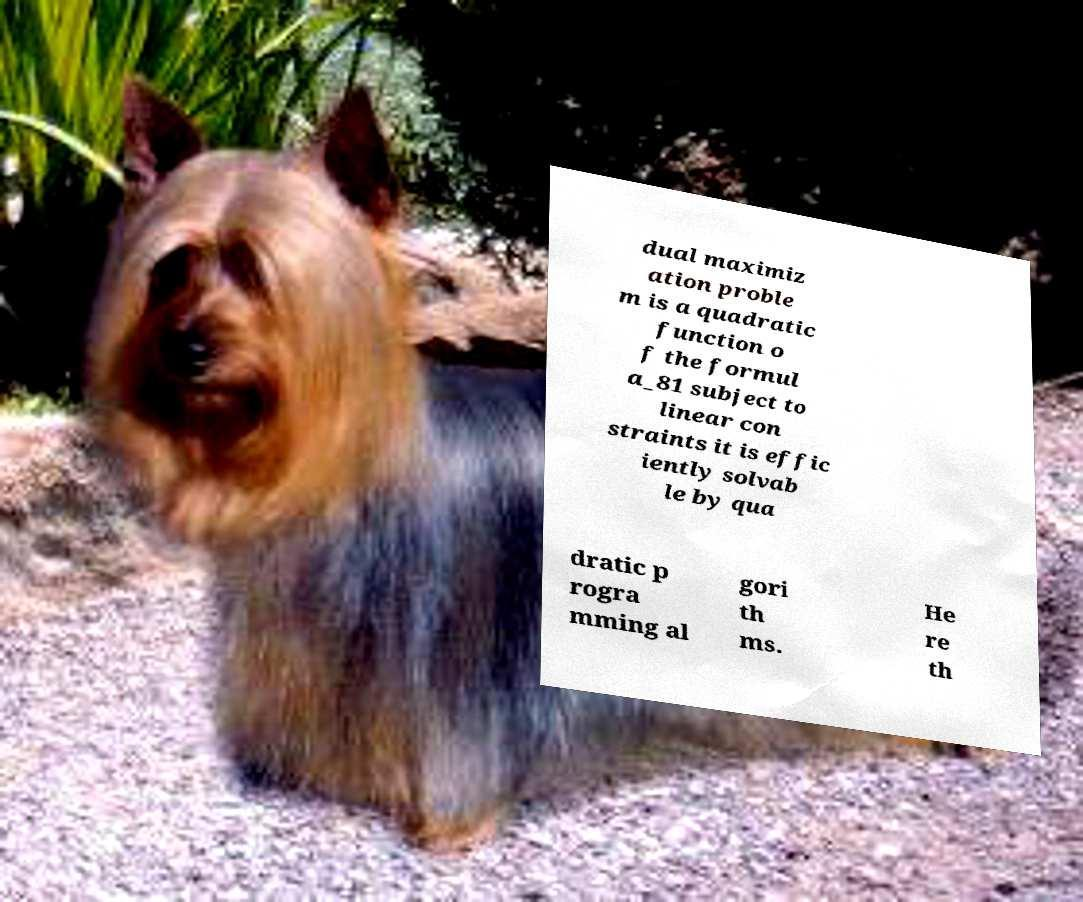Could you extract and type out the text from this image? dual maximiz ation proble m is a quadratic function o f the formul a_81 subject to linear con straints it is effic iently solvab le by qua dratic p rogra mming al gori th ms. He re th 